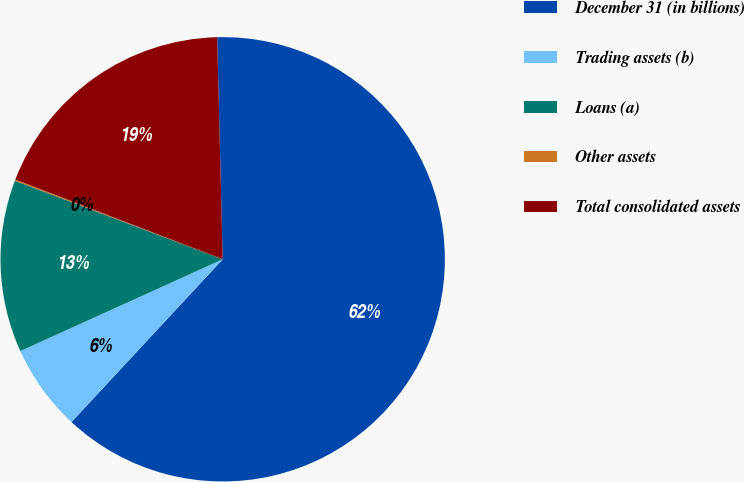<chart> <loc_0><loc_0><loc_500><loc_500><pie_chart><fcel>December 31 (in billions)<fcel>Trading assets (b)<fcel>Loans (a)<fcel>Other assets<fcel>Total consolidated assets<nl><fcel>62.31%<fcel>6.31%<fcel>12.53%<fcel>0.09%<fcel>18.76%<nl></chart> 